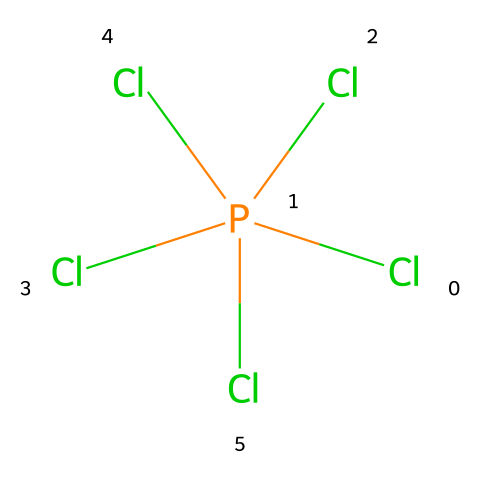What is the name of this chemical? The chemical represented is phosphorus pentachloride, which can be inferred from the presence of one phosphorus atom and five chlorine atoms in the structure.
Answer: phosphorus pentachloride How many chlorine atoms are present in this compound? By examining the SMILES representation, there are five chlorine atoms bonded to one phosphorus atom.
Answer: five What is the central atom in this molecule? The central atom is phosphorus, as it is the only non-chlorine atom present and is bonded to multiple chlorine atoms.
Answer: phosphorus What type of hybridization does the phosphorus atom exhibit? In phosphorus pentachloride, the phosphorus atom is surrounded by five chlorine atoms, indicating a trigonal bipyramidal arrangement, which corresponds to sp3d hybridization.
Answer: sp3d Why is phosphorus pentachloride considered a hypervalent compound? Phosphorus pentachloride is labeled as hypervalent because the phosphorus atom has more than four bonds, which exceeds the typical octet rule that limits atoms to four bonds.
Answer: hypervalent What molecular geometry does phosphorus pentachloride display? The arrangement of five bonds around the phosphorus atom leads to a trigonal bipyramidal molecular geometry, which can be deduced from the positioning of the chlorine atoms in relation to each other.
Answer: trigonal bipyramidal How many total bonds does phosphorus pentachloride have? The phosphorus atom forms five single bonds with five chlorine atoms, resulting in a total of five bonds in the molecule.
Answer: five 